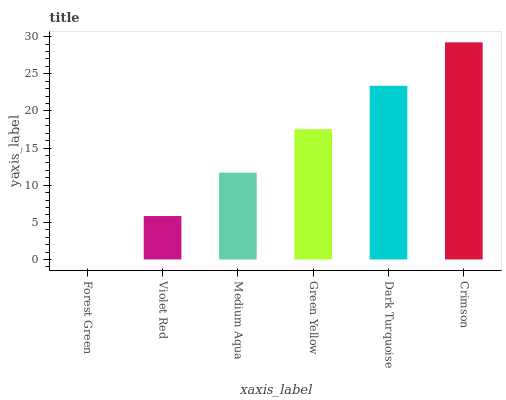Is Violet Red the minimum?
Answer yes or no. No. Is Violet Red the maximum?
Answer yes or no. No. Is Violet Red greater than Forest Green?
Answer yes or no. Yes. Is Forest Green less than Violet Red?
Answer yes or no. Yes. Is Forest Green greater than Violet Red?
Answer yes or no. No. Is Violet Red less than Forest Green?
Answer yes or no. No. Is Green Yellow the high median?
Answer yes or no. Yes. Is Medium Aqua the low median?
Answer yes or no. Yes. Is Crimson the high median?
Answer yes or no. No. Is Violet Red the low median?
Answer yes or no. No. 